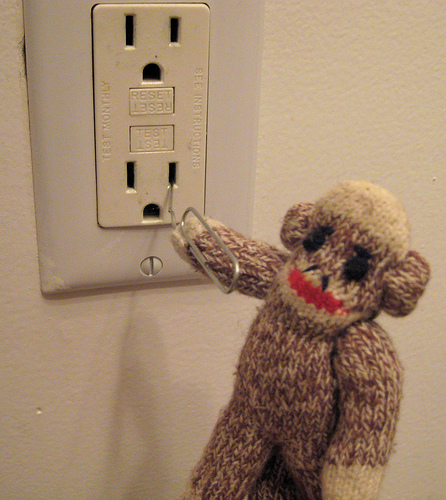<image>
Is there a paper clip behind the monkey? No. The paper clip is not behind the monkey. From this viewpoint, the paper clip appears to be positioned elsewhere in the scene. Is there a teddy on the plug point? No. The teddy is not positioned on the plug point. They may be near each other, but the teddy is not supported by or resting on top of the plug point. 